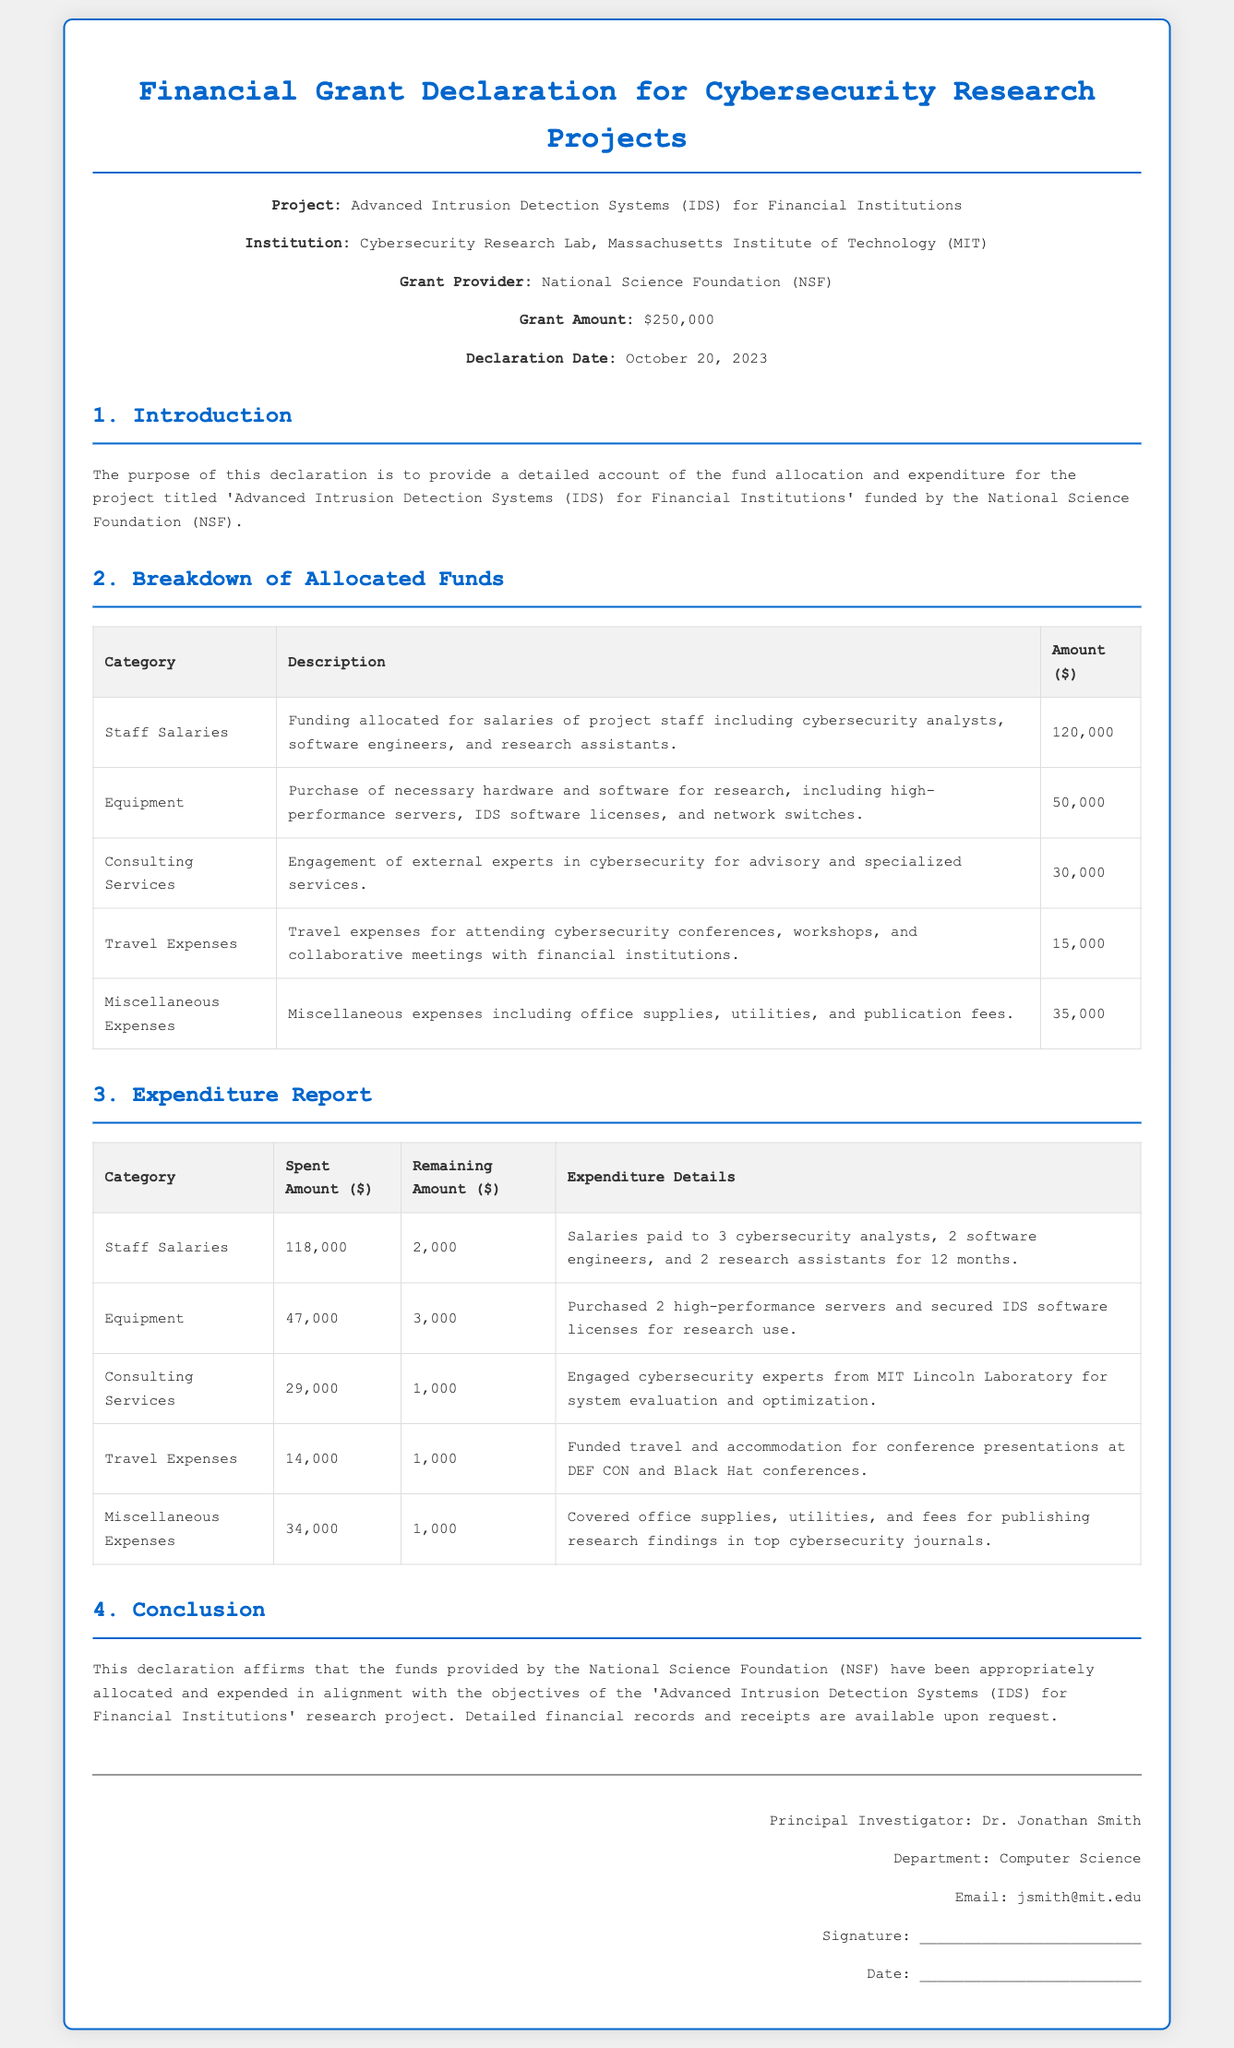What is the grant amount? The document states that the grant amount is funded by the National Science Foundation (NSF) for the project.
Answer: $250,000 Who is the principal investigator? The document lists the principal investigator's name as part of the signature section.
Answer: Dr. Jonathan Smith What is the total amount spent on staff salaries? The expenditure report specifies the amount spent on staff salaries in the document.
Answer: $118,000 How much was allocated for equipment? The breakdown of allocated funds indicates the amount designated for equipment purchases.
Answer: $50,000 What are the remaining amounts for travel expenses? The expenditure report provides the remaining amount for travel expenses after accounting for expenditures.
Answer: $1,000 Which institution is affiliated with the research project? The declaration specifies the institution conducting the research project as part of the header information.
Answer: Massachusetts Institute of Technology (MIT) What percentage of the total grant has been spent so far? The total spent is $329,000 ($118,000 + $47,000 + $29,000 + $14,000 + $34,000) which relates to the total grant amount of $250,000. Since the expenditure exceeds the grant, this question is impossible to answer directly as presented.
Answer: N/A What is the purpose of this declaration? The introduction outlines the aim of the declaration as relating to fund allocation and expenditure.
Answer: Provide a detailed account of fund allocation and expenditure How much is allocated for miscellaneous expenses? The breakdown of allocated funds includes a specific amount for miscellaneous expenses.
Answer: $35,000 What is the declaration date? The document includes the specific date when the declaration is formally dated.
Answer: October 20, 2023 